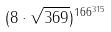<formula> <loc_0><loc_0><loc_500><loc_500>( 8 \cdot \sqrt { 3 6 9 } ) ^ { 1 6 6 ^ { 3 1 5 } }</formula> 